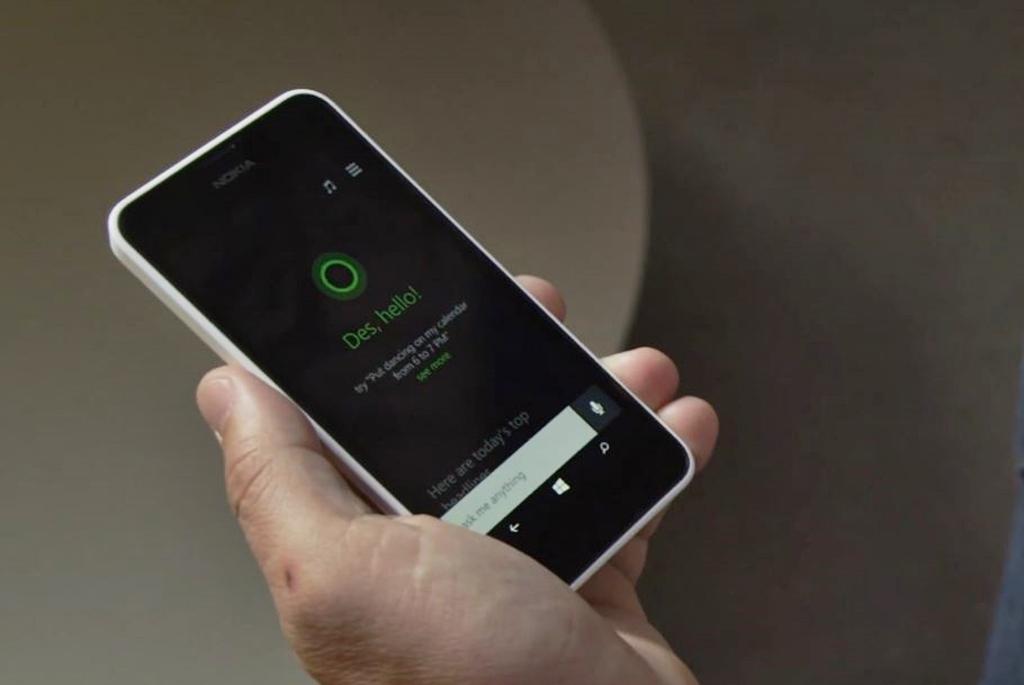What does it say in the white box?
Offer a very short reply. Ask me anything. 